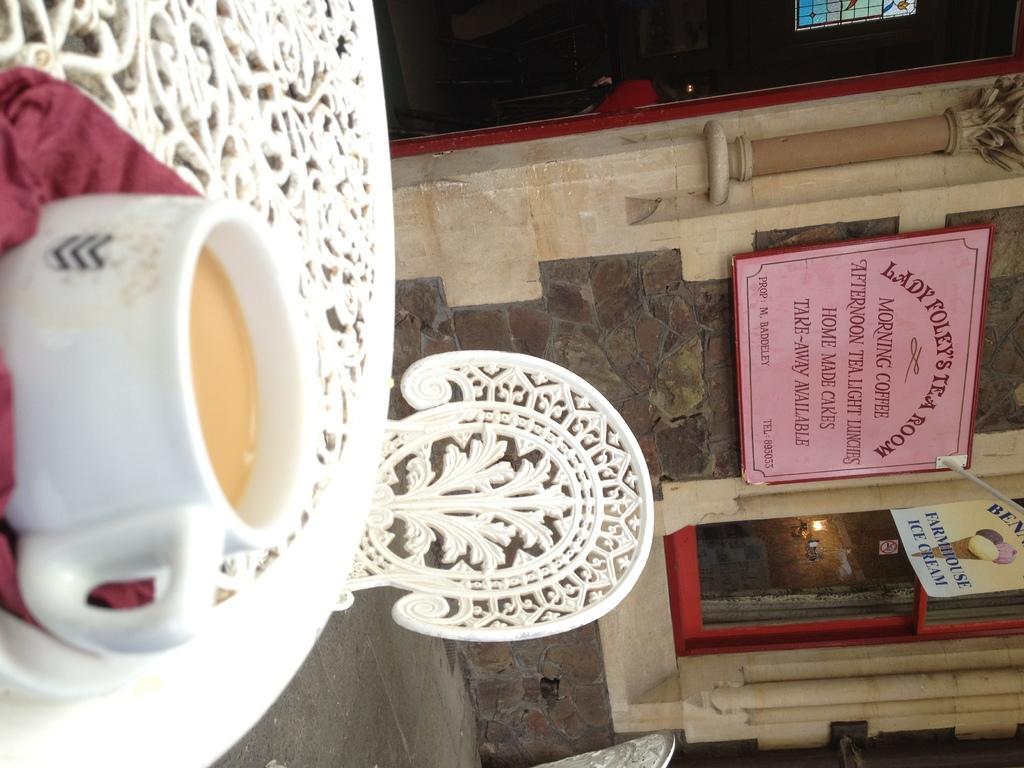Could you give a brief overview of what you see in this image? In the foreground of this image, there is a table on which a cup of tea in a saucer is placed. In the background, we can see a chair, wall, pillar, door, a name board, a window and the surface. 